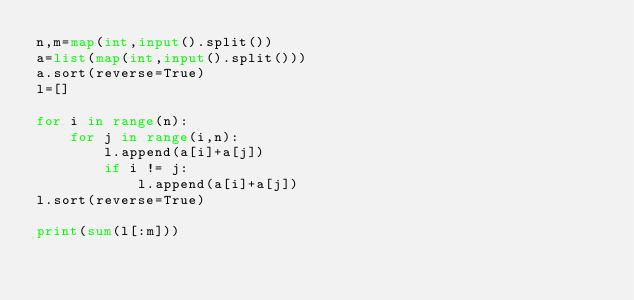<code> <loc_0><loc_0><loc_500><loc_500><_Python_>n,m=map(int,input().split())
a=list(map(int,input().split()))
a.sort(reverse=True)
l=[]

for i in range(n):
    for j in range(i,n):
        l.append(a[i]+a[j])
        if i != j:
            l.append(a[i]+a[j])
l.sort(reverse=True)

print(sum(l[:m]))
</code> 